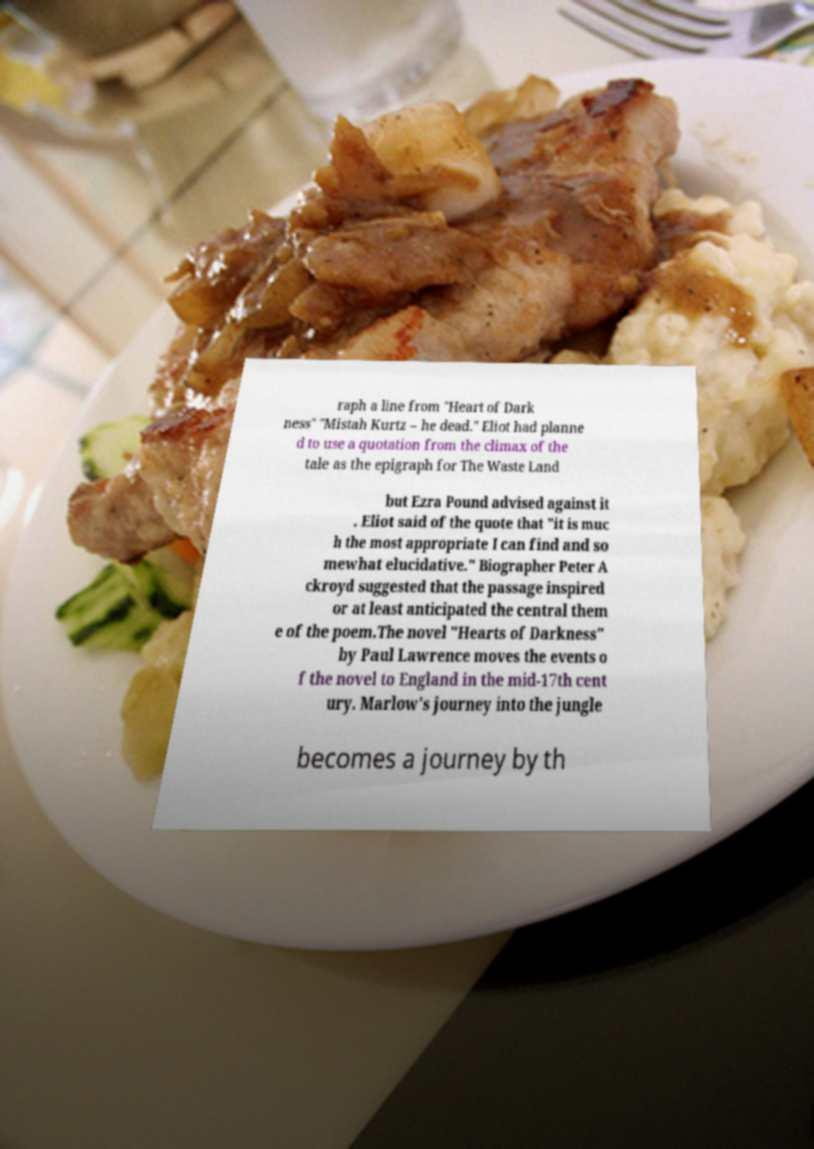Could you assist in decoding the text presented in this image and type it out clearly? raph a line from "Heart of Dark ness" "Mistah Kurtz – he dead." Eliot had planne d to use a quotation from the climax of the tale as the epigraph for The Waste Land but Ezra Pound advised against it . Eliot said of the quote that "it is muc h the most appropriate I can find and so mewhat elucidative." Biographer Peter A ckroyd suggested that the passage inspired or at least anticipated the central them e of the poem.The novel "Hearts of Darkness" by Paul Lawrence moves the events o f the novel to England in the mid-17th cent ury. Marlow's journey into the jungle becomes a journey by th 